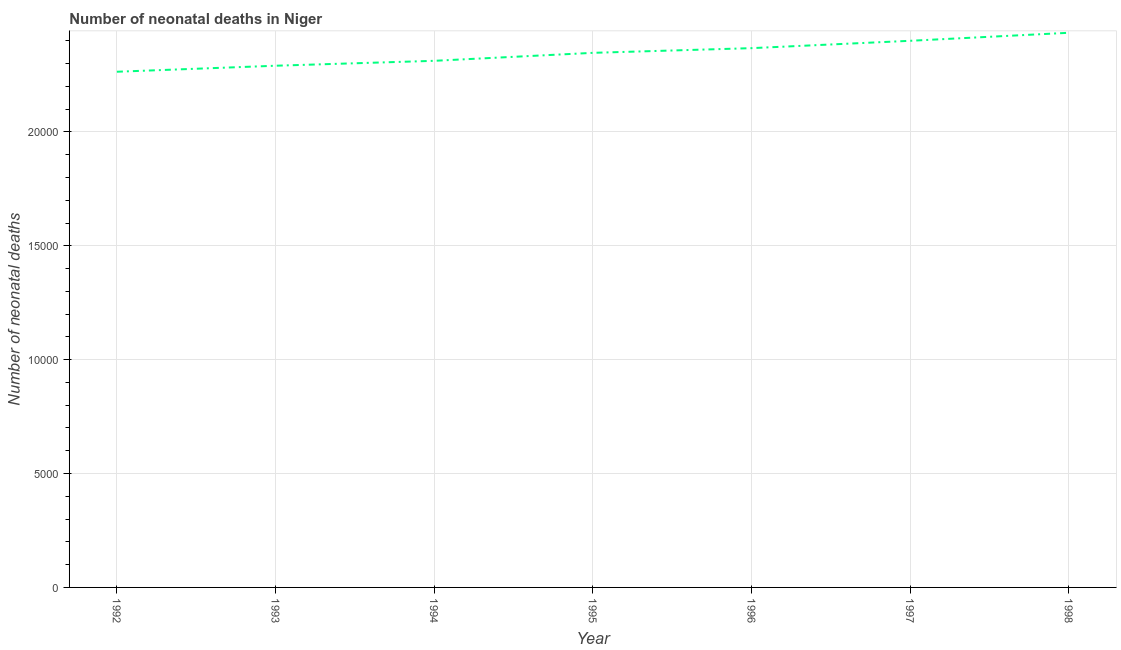What is the number of neonatal deaths in 1993?
Make the answer very short. 2.29e+04. Across all years, what is the maximum number of neonatal deaths?
Provide a succinct answer. 2.44e+04. Across all years, what is the minimum number of neonatal deaths?
Your response must be concise. 2.26e+04. In which year was the number of neonatal deaths maximum?
Give a very brief answer. 1998. What is the sum of the number of neonatal deaths?
Offer a terse response. 1.64e+05. What is the difference between the number of neonatal deaths in 1996 and 1998?
Provide a short and direct response. -675. What is the average number of neonatal deaths per year?
Keep it short and to the point. 2.35e+04. What is the median number of neonatal deaths?
Give a very brief answer. 2.35e+04. In how many years, is the number of neonatal deaths greater than 19000 ?
Offer a terse response. 7. What is the ratio of the number of neonatal deaths in 1992 to that in 1995?
Your answer should be very brief. 0.96. Is the number of neonatal deaths in 1997 less than that in 1998?
Your answer should be compact. Yes. Is the difference between the number of neonatal deaths in 1995 and 1998 greater than the difference between any two years?
Give a very brief answer. No. What is the difference between the highest and the second highest number of neonatal deaths?
Offer a terse response. 352. What is the difference between the highest and the lowest number of neonatal deaths?
Give a very brief answer. 1711. In how many years, is the number of neonatal deaths greater than the average number of neonatal deaths taken over all years?
Your answer should be compact. 4. Does the number of neonatal deaths monotonically increase over the years?
Keep it short and to the point. Yes. How many years are there in the graph?
Give a very brief answer. 7. What is the difference between two consecutive major ticks on the Y-axis?
Ensure brevity in your answer.  5000. Are the values on the major ticks of Y-axis written in scientific E-notation?
Make the answer very short. No. Does the graph contain any zero values?
Provide a short and direct response. No. Does the graph contain grids?
Your response must be concise. Yes. What is the title of the graph?
Keep it short and to the point. Number of neonatal deaths in Niger. What is the label or title of the X-axis?
Provide a short and direct response. Year. What is the label or title of the Y-axis?
Your answer should be very brief. Number of neonatal deaths. What is the Number of neonatal deaths in 1992?
Provide a succinct answer. 2.26e+04. What is the Number of neonatal deaths of 1993?
Give a very brief answer. 2.29e+04. What is the Number of neonatal deaths in 1994?
Offer a terse response. 2.31e+04. What is the Number of neonatal deaths of 1995?
Provide a short and direct response. 2.35e+04. What is the Number of neonatal deaths of 1996?
Make the answer very short. 2.37e+04. What is the Number of neonatal deaths in 1997?
Offer a terse response. 2.40e+04. What is the Number of neonatal deaths in 1998?
Ensure brevity in your answer.  2.44e+04. What is the difference between the Number of neonatal deaths in 1992 and 1993?
Give a very brief answer. -264. What is the difference between the Number of neonatal deaths in 1992 and 1994?
Your answer should be compact. -480. What is the difference between the Number of neonatal deaths in 1992 and 1995?
Your answer should be compact. -830. What is the difference between the Number of neonatal deaths in 1992 and 1996?
Ensure brevity in your answer.  -1036. What is the difference between the Number of neonatal deaths in 1992 and 1997?
Provide a short and direct response. -1359. What is the difference between the Number of neonatal deaths in 1992 and 1998?
Offer a very short reply. -1711. What is the difference between the Number of neonatal deaths in 1993 and 1994?
Provide a succinct answer. -216. What is the difference between the Number of neonatal deaths in 1993 and 1995?
Your answer should be very brief. -566. What is the difference between the Number of neonatal deaths in 1993 and 1996?
Provide a short and direct response. -772. What is the difference between the Number of neonatal deaths in 1993 and 1997?
Your response must be concise. -1095. What is the difference between the Number of neonatal deaths in 1993 and 1998?
Provide a short and direct response. -1447. What is the difference between the Number of neonatal deaths in 1994 and 1995?
Offer a very short reply. -350. What is the difference between the Number of neonatal deaths in 1994 and 1996?
Provide a short and direct response. -556. What is the difference between the Number of neonatal deaths in 1994 and 1997?
Ensure brevity in your answer.  -879. What is the difference between the Number of neonatal deaths in 1994 and 1998?
Your response must be concise. -1231. What is the difference between the Number of neonatal deaths in 1995 and 1996?
Your answer should be very brief. -206. What is the difference between the Number of neonatal deaths in 1995 and 1997?
Your answer should be compact. -529. What is the difference between the Number of neonatal deaths in 1995 and 1998?
Your answer should be very brief. -881. What is the difference between the Number of neonatal deaths in 1996 and 1997?
Offer a very short reply. -323. What is the difference between the Number of neonatal deaths in 1996 and 1998?
Ensure brevity in your answer.  -675. What is the difference between the Number of neonatal deaths in 1997 and 1998?
Provide a short and direct response. -352. What is the ratio of the Number of neonatal deaths in 1992 to that in 1995?
Your answer should be compact. 0.96. What is the ratio of the Number of neonatal deaths in 1992 to that in 1996?
Keep it short and to the point. 0.96. What is the ratio of the Number of neonatal deaths in 1992 to that in 1997?
Provide a short and direct response. 0.94. What is the ratio of the Number of neonatal deaths in 1993 to that in 1995?
Keep it short and to the point. 0.98. What is the ratio of the Number of neonatal deaths in 1993 to that in 1997?
Your answer should be very brief. 0.95. What is the ratio of the Number of neonatal deaths in 1993 to that in 1998?
Give a very brief answer. 0.94. What is the ratio of the Number of neonatal deaths in 1994 to that in 1995?
Offer a very short reply. 0.98. What is the ratio of the Number of neonatal deaths in 1994 to that in 1996?
Offer a very short reply. 0.98. What is the ratio of the Number of neonatal deaths in 1994 to that in 1998?
Your answer should be very brief. 0.95. What is the ratio of the Number of neonatal deaths in 1995 to that in 1996?
Your response must be concise. 0.99. What is the ratio of the Number of neonatal deaths in 1996 to that in 1997?
Give a very brief answer. 0.99. 